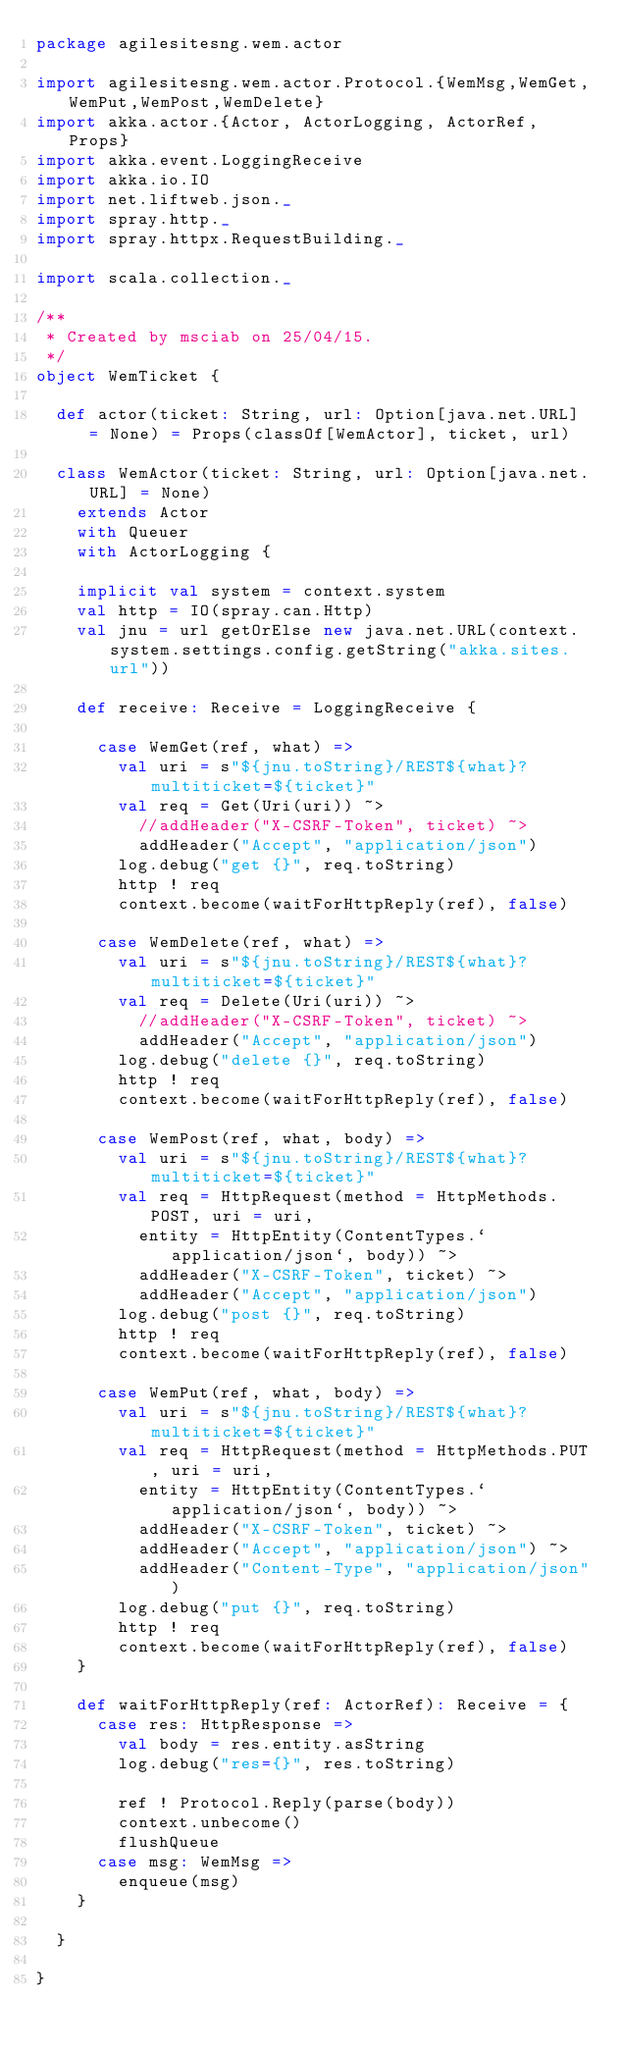<code> <loc_0><loc_0><loc_500><loc_500><_Scala_>package agilesitesng.wem.actor

import agilesitesng.wem.actor.Protocol.{WemMsg,WemGet,WemPut,WemPost,WemDelete}
import akka.actor.{Actor, ActorLogging, ActorRef, Props}
import akka.event.LoggingReceive
import akka.io.IO
import net.liftweb.json._
import spray.http._
import spray.httpx.RequestBuilding._

import scala.collection._

/**
 * Created by msciab on 25/04/15.
 */
object WemTicket {

  def actor(ticket: String, url: Option[java.net.URL] = None) = Props(classOf[WemActor], ticket, url)

  class WemActor(ticket: String, url: Option[java.net.URL] = None)
    extends Actor
    with Queuer
    with ActorLogging {

    implicit val system = context.system
    val http = IO(spray.can.Http)
    val jnu = url getOrElse new java.net.URL(context.system.settings.config.getString("akka.sites.url"))

    def receive: Receive = LoggingReceive {

      case WemGet(ref, what) =>
        val uri = s"${jnu.toString}/REST${what}?multiticket=${ticket}"
        val req = Get(Uri(uri)) ~>
          //addHeader("X-CSRF-Token", ticket) ~>
          addHeader("Accept", "application/json")
        log.debug("get {}", req.toString)
        http ! req
        context.become(waitForHttpReply(ref), false)

      case WemDelete(ref, what) =>
        val uri = s"${jnu.toString}/REST${what}?multiticket=${ticket}"
        val req = Delete(Uri(uri)) ~>
          //addHeader("X-CSRF-Token", ticket) ~>
          addHeader("Accept", "application/json")
        log.debug("delete {}", req.toString)
        http ! req
        context.become(waitForHttpReply(ref), false)

      case WemPost(ref, what, body) =>
        val uri = s"${jnu.toString}/REST${what}?multiticket=${ticket}"
        val req = HttpRequest(method = HttpMethods.POST, uri = uri,
          entity = HttpEntity(ContentTypes.`application/json`, body)) ~>
          addHeader("X-CSRF-Token", ticket) ~>
          addHeader("Accept", "application/json")
        log.debug("post {}", req.toString)
        http ! req
        context.become(waitForHttpReply(ref), false)

      case WemPut(ref, what, body) =>
        val uri = s"${jnu.toString}/REST${what}?multiticket=${ticket}"
        val req = HttpRequest(method = HttpMethods.PUT, uri = uri,
          entity = HttpEntity(ContentTypes.`application/json`, body)) ~>
          addHeader("X-CSRF-Token", ticket) ~>
          addHeader("Accept", "application/json") ~>
          addHeader("Content-Type", "application/json")
        log.debug("put {}", req.toString)
        http ! req
        context.become(waitForHttpReply(ref), false)
    }

    def waitForHttpReply(ref: ActorRef): Receive = {
      case res: HttpResponse =>
        val body = res.entity.asString
        log.debug("res={}", res.toString)

        ref ! Protocol.Reply(parse(body))
        context.unbecome()
        flushQueue
      case msg: WemMsg =>
        enqueue(msg)
    }

  }

}
</code> 